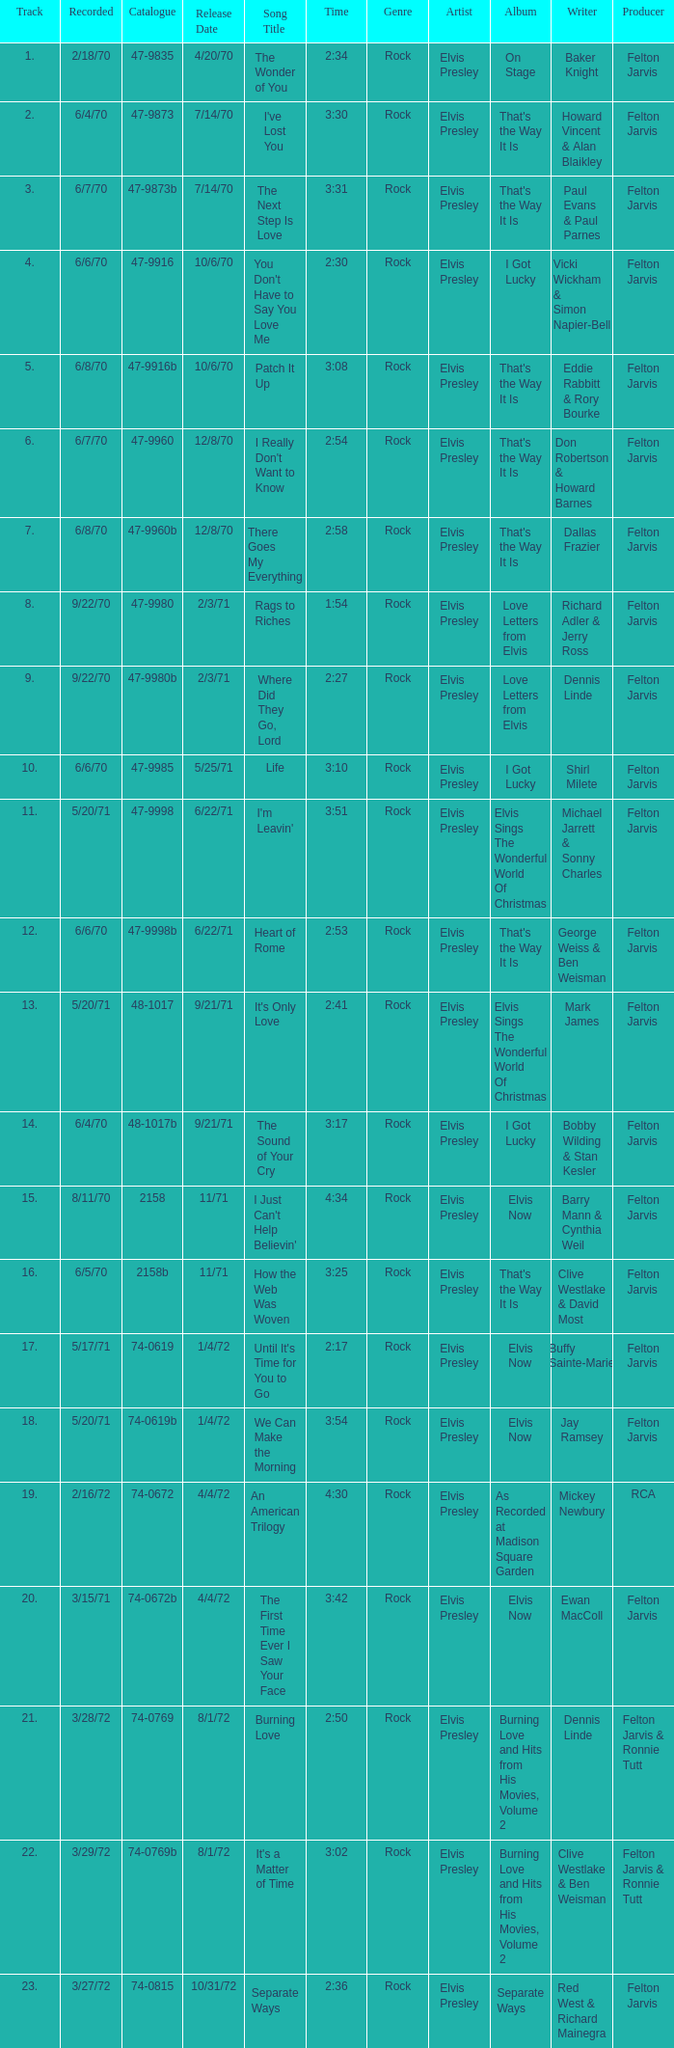What is the highest track for Burning Love? 21.0. 